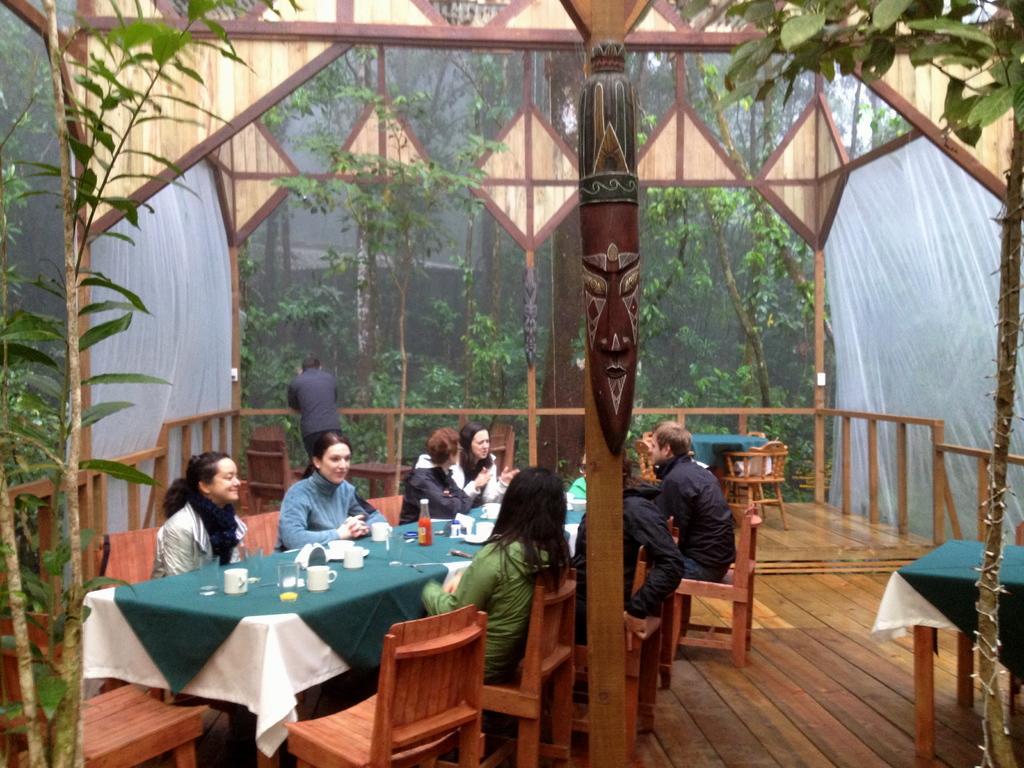Please provide a concise description of this image. There are group of people sitting in chairs and there is a table in front of them which consists of cup,glass and there are trees around them. 